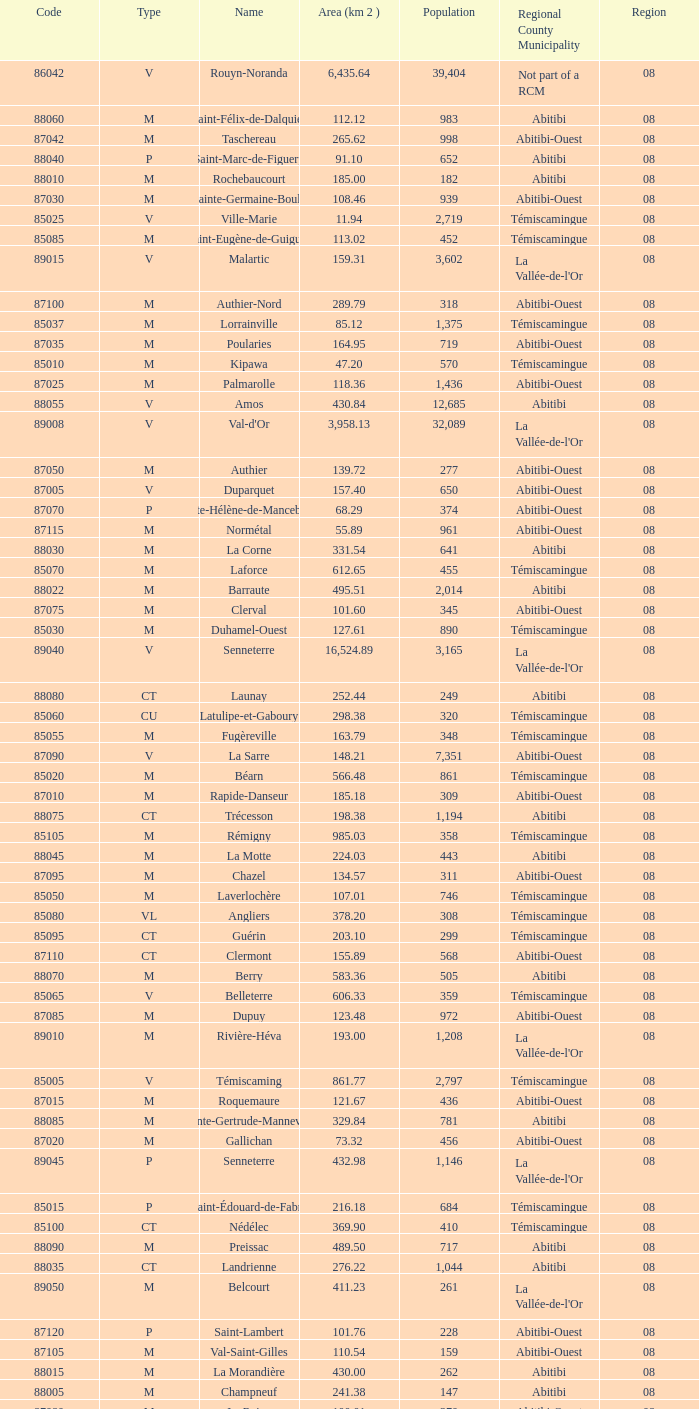What type has a population of 370? M. 